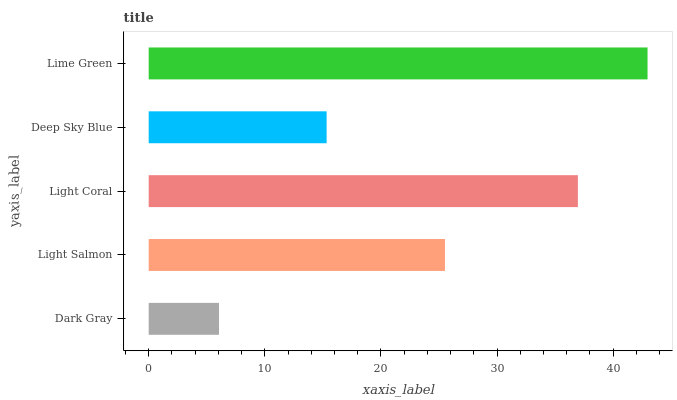Is Dark Gray the minimum?
Answer yes or no. Yes. Is Lime Green the maximum?
Answer yes or no. Yes. Is Light Salmon the minimum?
Answer yes or no. No. Is Light Salmon the maximum?
Answer yes or no. No. Is Light Salmon greater than Dark Gray?
Answer yes or no. Yes. Is Dark Gray less than Light Salmon?
Answer yes or no. Yes. Is Dark Gray greater than Light Salmon?
Answer yes or no. No. Is Light Salmon less than Dark Gray?
Answer yes or no. No. Is Light Salmon the high median?
Answer yes or no. Yes. Is Light Salmon the low median?
Answer yes or no. Yes. Is Dark Gray the high median?
Answer yes or no. No. Is Light Coral the low median?
Answer yes or no. No. 